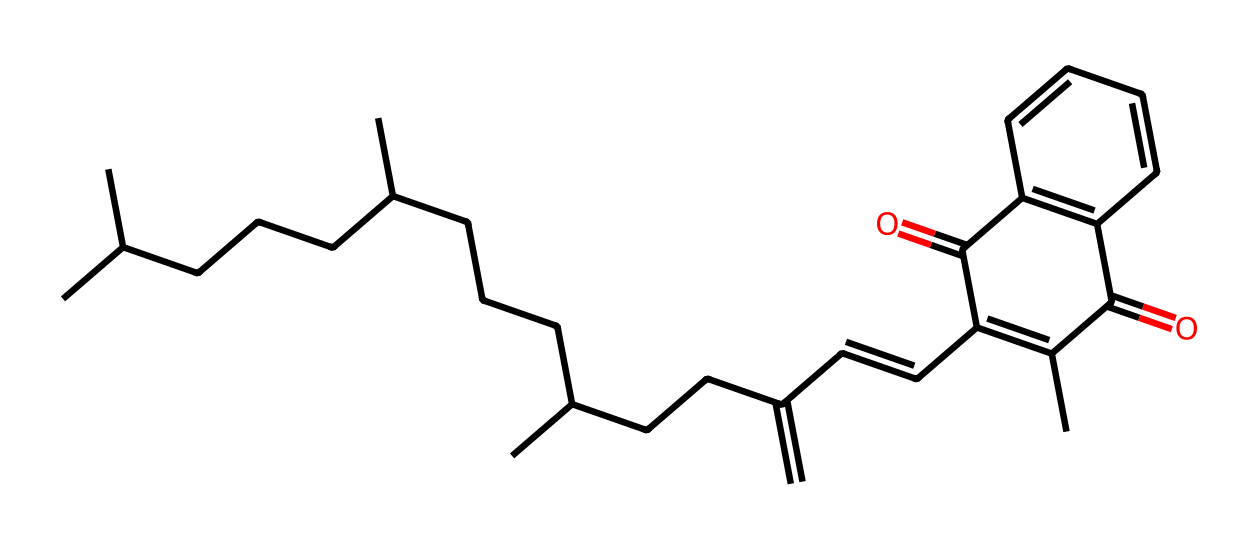What is the name of this vitamin? The structure corresponds to vitamin K, which is recognized for its role in blood clotting.
Answer: vitamin K How many rings are in the structure? By examining the chemical structure, there are two distinct rings in the molecular arrangement.
Answer: 2 What type of bonds are predominantly found in this structure? The presence of multiple carbon-carbon and carbon-oxygen bonds suggests that this chemical primarily features covalent bonds.
Answer: covalent bonds Why is the molecular arrangement significant for blood clotting? The specific arrangement of certain functional groups allows vitamin K to participate in the carboxylation of proteins essential for coagulation, which is critical especially for those with reduced physical activity.
Answer: coagulation What functional group is present that aids in its biological activity? The presence of a ketone group in the structure is crucial for its biological function related to clotting mechanisms.
Answer: ketone group How does the size of this molecule influence its function in the body? The larger size allows for better interaction with lipid membranes, facilitating its role in the absorption of vitamin K and thus its availability for blood clotting activities.
Answer: better interaction What type of vitamin is vitamin K classified as? Vitamin K is classified as a fat-soluble vitamin due to its solubility in lipids and its significant roles in metabolic processes involving fats.
Answer: fat-soluble 